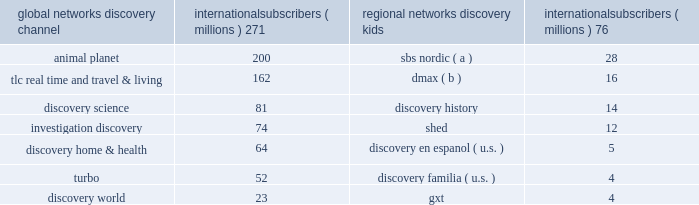Our international networks segment owns and operates the following television networks , which reached the following number of subscribers via pay television services as of december 31 , 2013 : global networks international subscribers ( millions ) regional networks international subscribers ( millions ) .
( a ) number of subscribers corresponds to the collective sum of the total number of subscribers to each of the sbs nordic broadcast networks in sweden , norway , and denmark subject to retransmission agreements with pay television providers .
( b ) number of subscribers corresponds to dmax pay television networks in the u.k. , austria , switzerland and ireland .
Our international networks segment also owns and operates free-to-air television networks which reached 285 million cumulative viewers in europe and the middle east as of december 31 , 2013 .
Our free-to-air networks include dmax , fatafeat , quest , real time , giallo , frisbee , focus and k2 .
Similar to u.s .
Networks , the primary sources of revenue for international networks are fees charged to operators who distribute our networks , which primarily include cable and dth satellite service providers , and advertising sold on our television networks .
International television markets vary in their stages of development .
Some markets , such as the u.k. , are more advanced digital television markets , while others remain in the analog environment with varying degrees of investment from operators to expand channel capacity or convert to digital technologies .
Common practice in some markets results in long-term contractual distribution relationships , while customers in other markets renew contracts annually .
Distribution revenue for our international networks segment is largely dependent on the number of subscribers that receive our networks or content , the rates negotiated in the agreements , and the market demand for the content that we provide .
Advertising revenue is dependent upon a number of factors including the development of pay and free-to-air television markets , the number of subscribers to and viewers of our channels , viewership demographics , the popularity of our programming , and our ability to sell commercial time over a group of channels .
In certain markets , our advertising sales business operates with in-house sales teams , while we rely on external sales representation services in other markets .
In developing television markets , we expect that advertising revenue growth will result from continued subscriber and viewership growth , our localization strategy , and the shift of advertising spending from traditional analog networks to channels in the multi-channel environment .
In relatively mature markets , such as western europe , growth in advertising revenue will come from increasing viewership and pricing of advertising on our existing television networks and the launching of new services , both organic and through acquisitions .
During 2013 , distribution , advertising and other revenues were 50% ( 50 % ) , 47% ( 47 % ) and 3% ( 3 % ) , respectively , of total net revenues for this segment .
On january 21 , 2014 , we entered into an agreement with tf1 to acquire a controlling interest in eurosport international ( "eurosport" ) , a leading pan-european sports media platform , by increasing our ownership stake from 20% ( 20 % ) to 51% ( 51 % ) for cash of approximately 20ac253 million ( $ 343 million ) subject to working capital adjustments .
Due to regulatory constraints the acquisition initially excludes eurosport france , a subsidiary of eurosport .
We will retain a 20% ( 20 % ) equity interest in eurosport france and a commitment to acquire another 31% ( 31 % ) ownership interest beginning 2015 , contingent upon resolution of all regulatory matters .
The flagship eurosport network focuses on regionally popular sports such as tennis , skiing , cycling and motor sports and reaches 133 million homes across 54 countries in 20 languages .
Eurosport 2019s brands and platforms also include eurosport hd ( high definition simulcast ) , eurosport 2 , eurosport 2 hd ( high definition simulcast ) , eurosport asia-pacific , and eurosportnews .
The acquisition is intended to increase the growth of eurosport and enhance our pay television offerings in europe .
Tf1 will have the right to put the entirety of its remaining 49% ( 49 % ) non-controlling interest to us for approximately two and a half years after completion of this acquisition .
The put has a floor value equal to the fair value at the acquisition date if exercised in the 90 day period beginning on july 1 , 2015 and is subsequently priced at fair value if exercised in the 90 day period beginning on july 1 , 2016 .
We expect the acquisition to close in the second quarter of 2014 subject to obtaining necessary regulatory approvals. .
What was the difference in millions of international subscribers between discovery channel and discovery science? 
Computations: (271 - 81)
Answer: 190.0. 